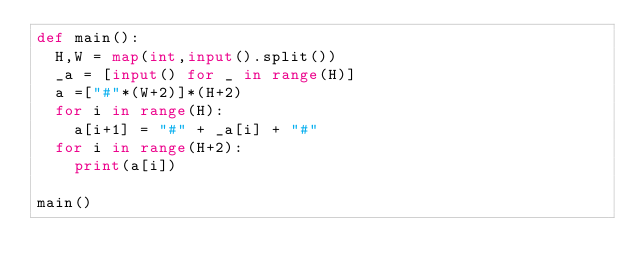Convert code to text. <code><loc_0><loc_0><loc_500><loc_500><_Python_>def main():
  H,W = map(int,input().split())
  _a = [input() for _ in range(H)]
  a =["#"*(W+2)]*(H+2)
  for i in range(H):
    a[i+1] = "#" + _a[i] + "#"
  for i in range(H+2):
    print(a[i])

main()  </code> 